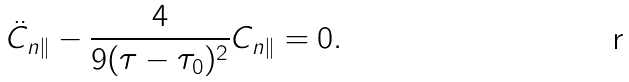<formula> <loc_0><loc_0><loc_500><loc_500>\ddot { C } _ { n \| } - \frac { 4 } { 9 ( \tau - \tau _ { 0 } ) ^ { 2 } } C _ { n \| } = 0 .</formula> 